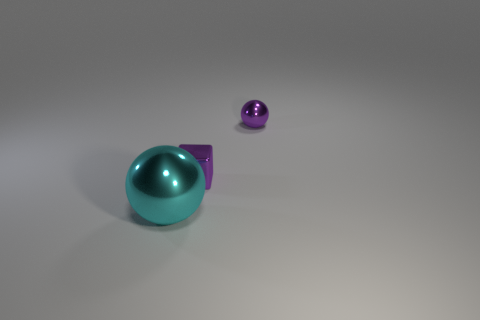Add 2 tiny green objects. How many objects exist? 5 Subtract all cubes. How many objects are left? 2 Subtract 0 gray balls. How many objects are left? 3 Subtract all large cyan objects. Subtract all big gray balls. How many objects are left? 2 Add 2 tiny objects. How many tiny objects are left? 4 Add 1 small shiny cubes. How many small shiny cubes exist? 2 